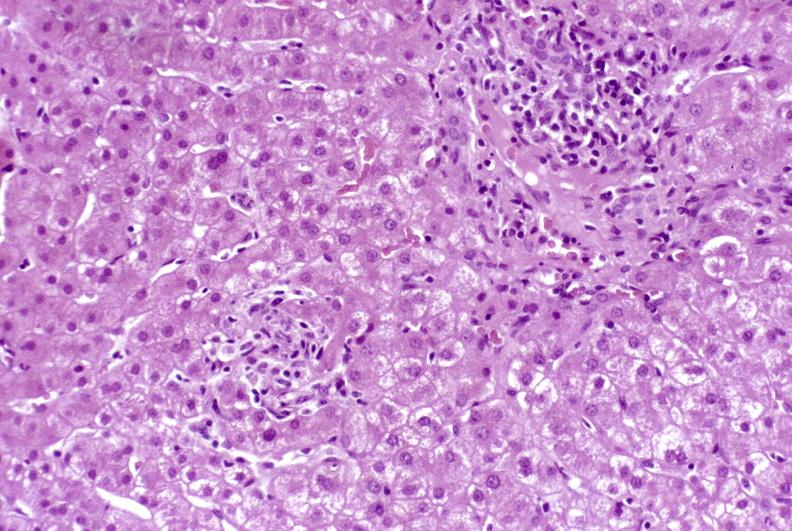what is present?
Answer the question using a single word or phrase. Liver 